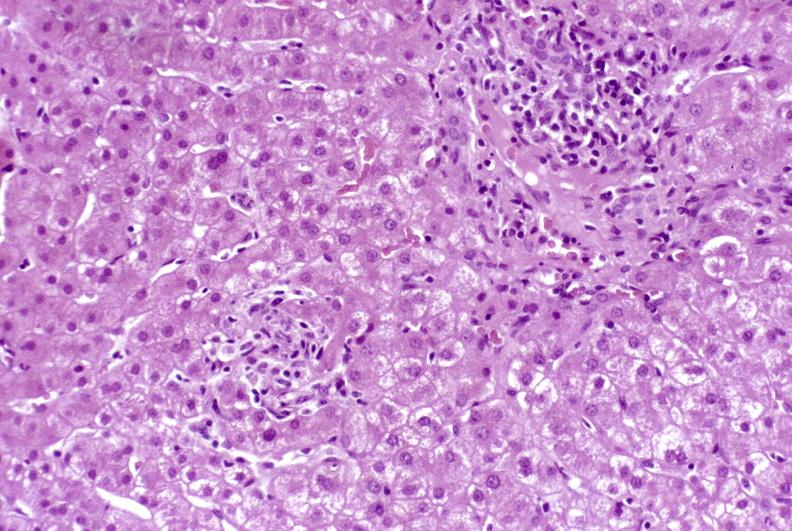what is present?
Answer the question using a single word or phrase. Liver 